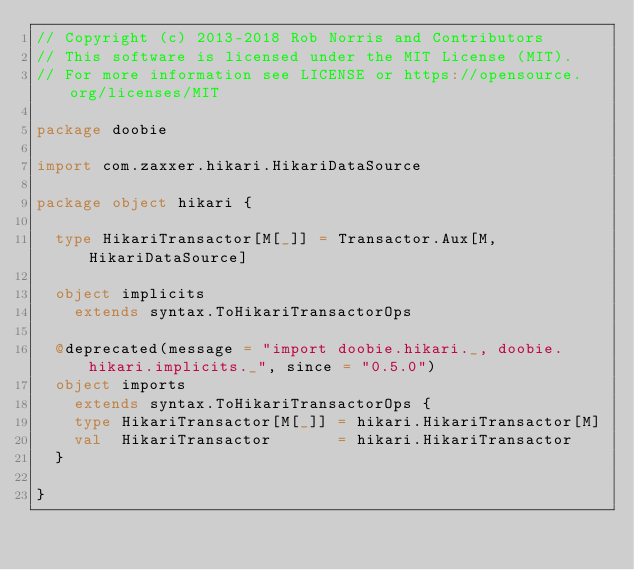<code> <loc_0><loc_0><loc_500><loc_500><_Scala_>// Copyright (c) 2013-2018 Rob Norris and Contributors
// This software is licensed under the MIT License (MIT).
// For more information see LICENSE or https://opensource.org/licenses/MIT

package doobie

import com.zaxxer.hikari.HikariDataSource

package object hikari {

  type HikariTransactor[M[_]] = Transactor.Aux[M, HikariDataSource]

  object implicits
    extends syntax.ToHikariTransactorOps

  @deprecated(message = "import doobie.hikari._, doobie.hikari.implicits._", since = "0.5.0")
  object imports
    extends syntax.ToHikariTransactorOps {
    type HikariTransactor[M[_]] = hikari.HikariTransactor[M]
    val  HikariTransactor       = hikari.HikariTransactor
  }

}
</code> 